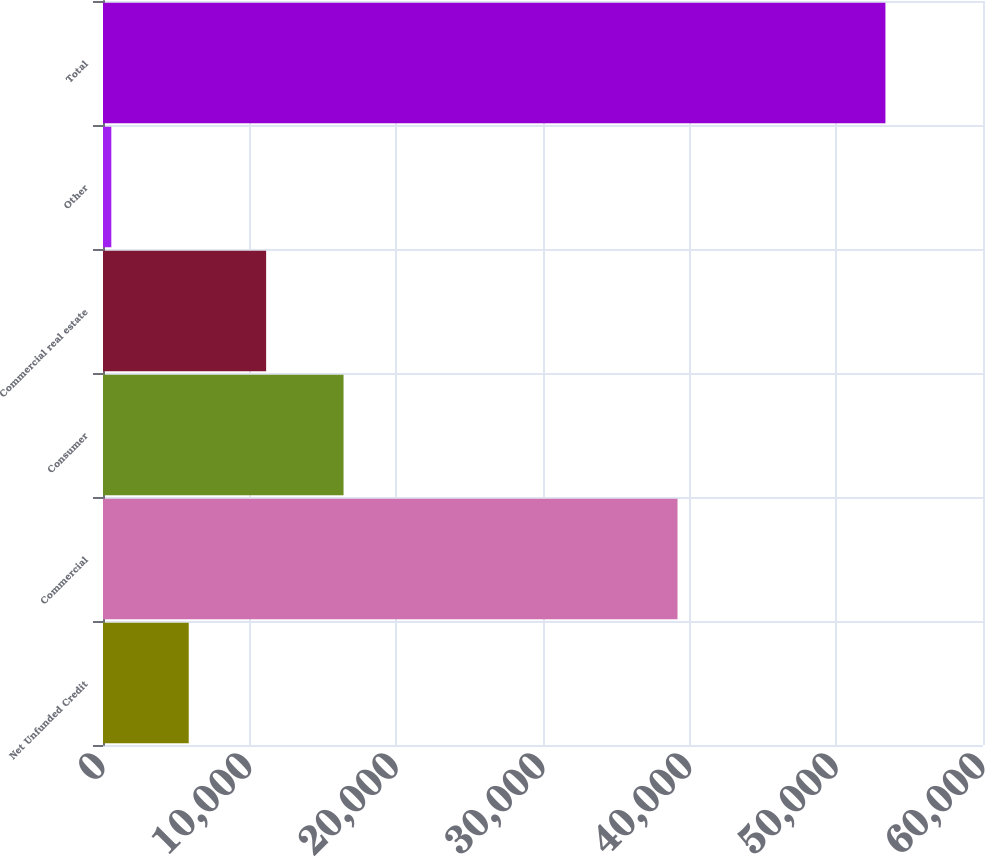<chart> <loc_0><loc_0><loc_500><loc_500><bar_chart><fcel>Net Unfunded Credit<fcel>Commercial<fcel>Consumer<fcel>Commercial real estate<fcel>Other<fcel>Total<nl><fcel>5845<fcel>39171<fcel>16401<fcel>11123<fcel>567<fcel>53347<nl></chart> 